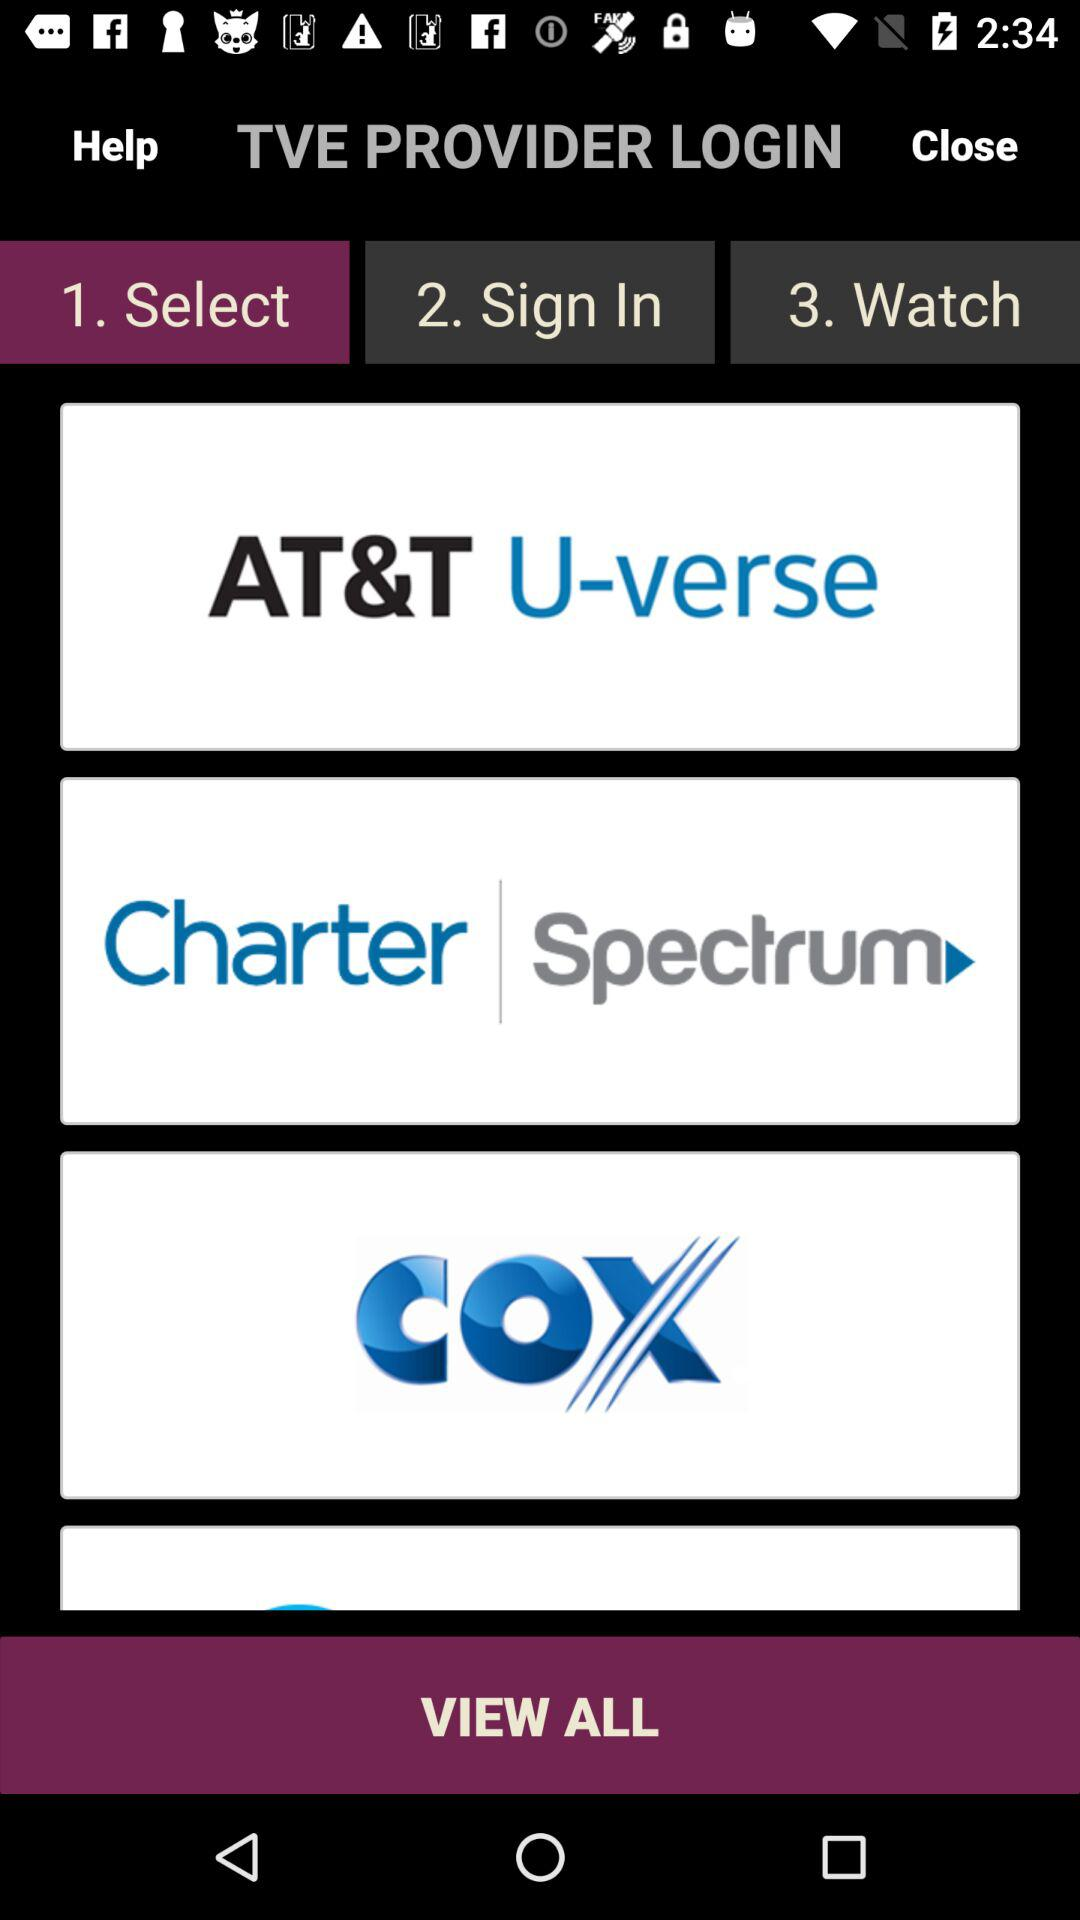What are the three steps for a TVE provider login? The three steps are: select, sign in and watch. 